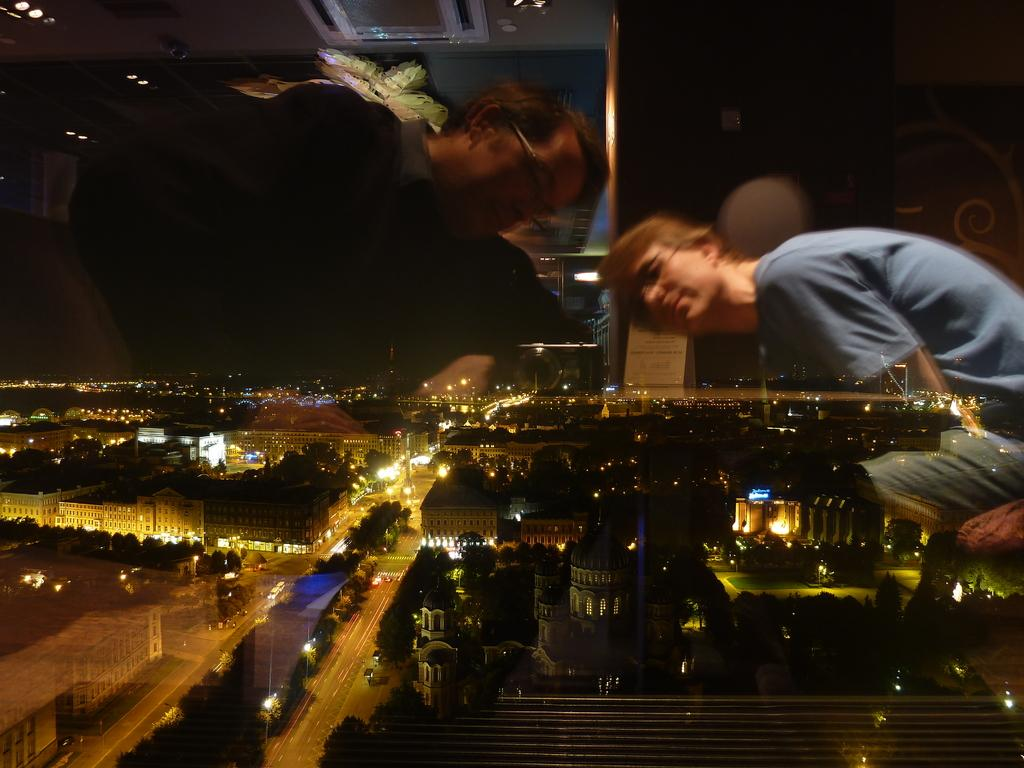How many people are sitting in the image? There are two people sitting in the image. What can be seen in the window? There is a reflection in the window, as well as buildings, streets, trees, and lights. What might the people be looking at through the window? The people might be looking at the buildings, streets, trees, and lights visible from the window. Can you tell me how many pictures are hanging on the wall in the image? There is no information about pictures hanging on the wall in the provided facts, so it cannot be determined from the image. What type of board is visible in the image? There is no board present in the image. 